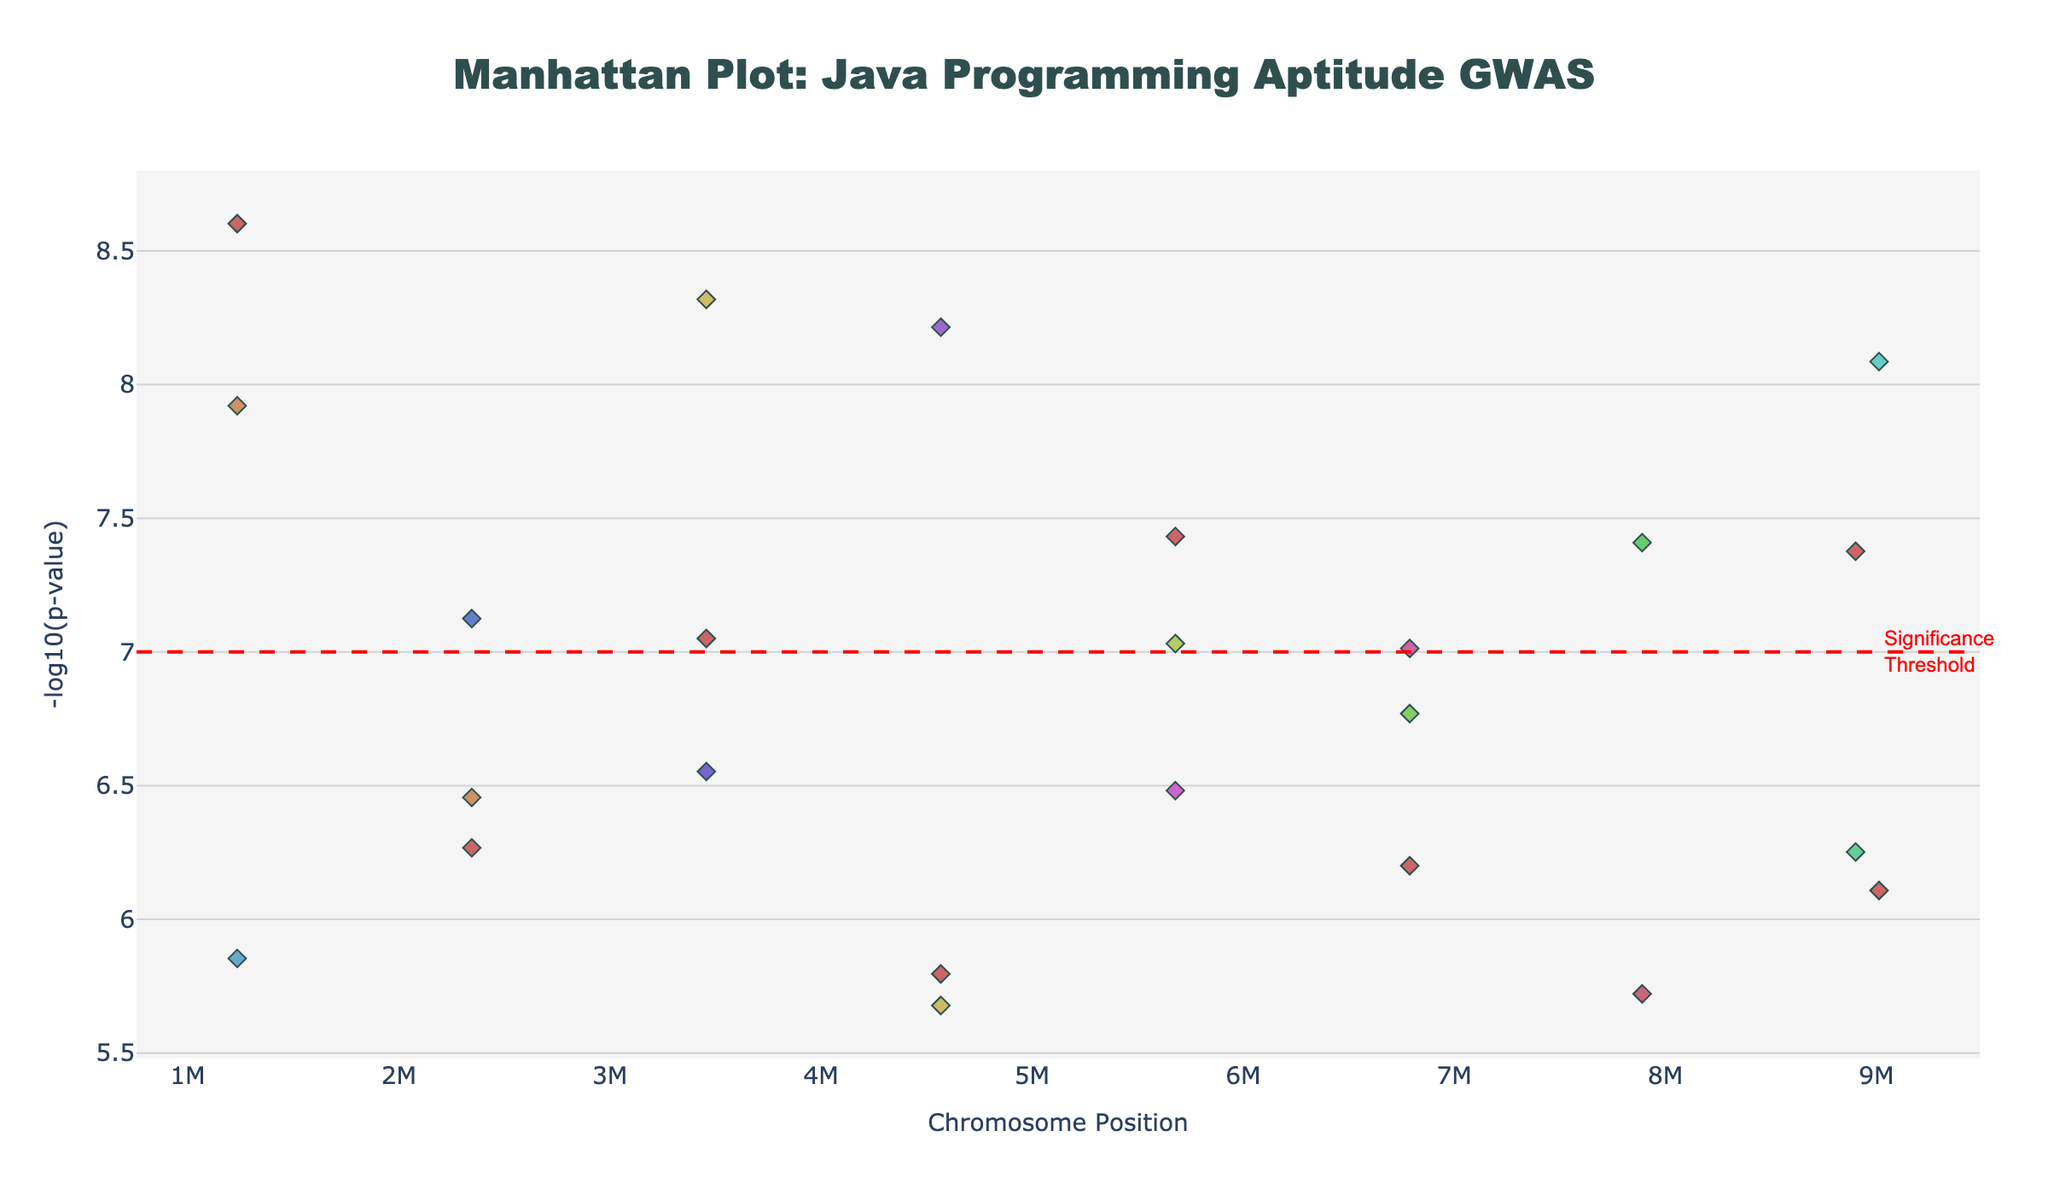What is the title of the Manhattan Plot? The title is placed at the top of the plot, centered, and it reads "Manhattan Plot: Java Programming Aptitude GWAS."
Answer: "Manhattan Plot: Java Programming Aptitude GWAS" How are the chromosomes visually differentiated in the plot? Chromosomes are differentiated using different colors, with each chromosome having a unique color that is represented in a hue spectrum.
Answer: Different colors Which SNP has the lowest p-value in the dataset? The SNP with the lowest p-value corresponds to the highest -log10(p-value) on the plot. The point with the highest y-value indicates SNP rs20001 with the lowest p-value of 4.8e-9 on Chromosome 2, positioned at 3456789.
Answer: rs20001 What does the red dashed line represent in the plot? The red dashed line is annotated and represents the significance threshold. It marks a specific level on the y-axis (7) corresponding to the -log10(p-value) threshold for statistical significance.
Answer: Significance threshold Which chromosome contains the highest number of significant SNPs? By observing the density of points above the threshold line (y=7), Chromosome 2 appears to have the highest number of points above this line, indicating the highest number of significant SNPs.
Answer: Chromosome 2 What trait is associated with the SNP rs170001 and what is its chromosomal position? Hovering over the point associated with SNP rs170001 reveals its trait and position. It is associated with "Code_Review_Proficiency" and is located at position 1234567 on Chromosome 17.
Answer: Code_Review_Proficiency at position 1234567 Which chromosomes have their data points showing below the significance threshold? By observing the plot, chromosomes 4, 8, 14, and 20 have data points mostly below the significance threshold line, indicating their p-values are not significantly low.
Answer: Chromosomes 4, 8, 14, and 20 How is the -log10(p-value) calculated from the p-value in the dataset? The -log10(p-value) is calculated by taking the negative base-10 logarithm of the p-value. For example, if the p-value is 1.2e-8, the -log10(p-value) is calculated as -log10(1.2e-8) which equals approximately 7.92.
Answer: -log10 of p-value What is the y-coordinate of the SNP related to "Spring_Framework_Mastery"? By identifying the specific SNP rs70001 on the plot, the y-coordinate corresponding to "Spring_Framework_Mastery" is found by its -log10(p-value), which is approximately 8.085.
Answer: Approximately 8.085 